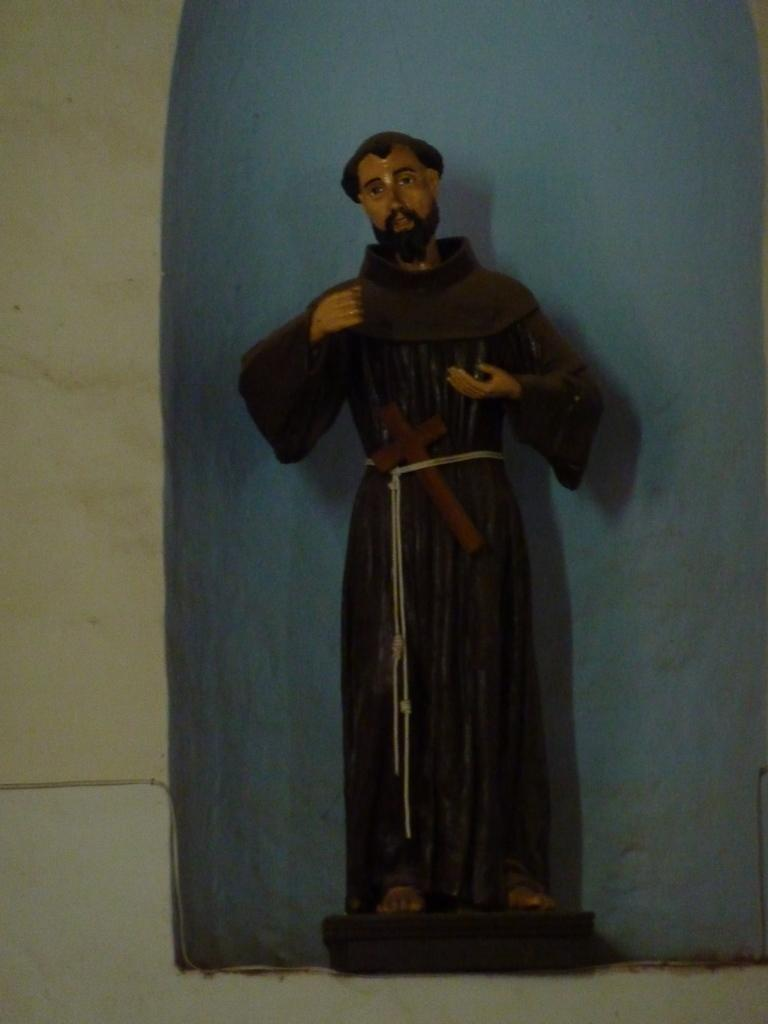What is the main subject of the image? The main subject of the image is a person's statue. What colors are used for the statue? The statue is in black and brown color. How would you describe the background of the image? The background of the image is in blue, white, and cream color. How much does the statue weigh in the image? The weight of the statue cannot be determined from the image alone. Is the person in the statue planning a trip to another city? There is no indication in the image that the statue is planning a trip or engaging in any activity. 